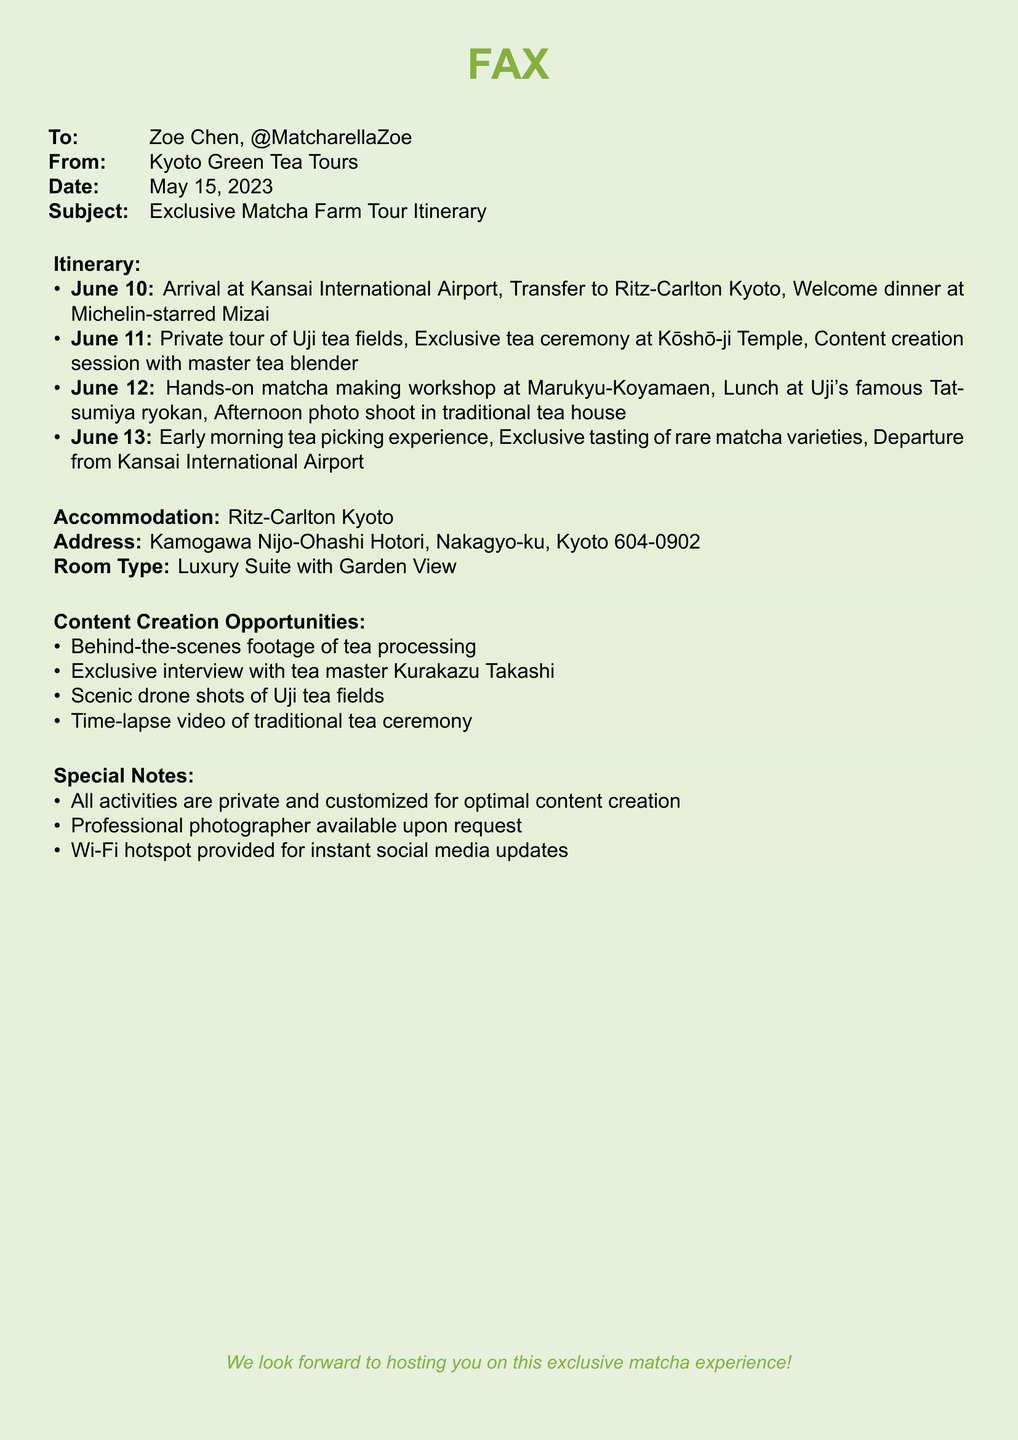What is the arrival date? The arrival date is mentioned in the itinerary for June 10.
Answer: June 10 What is the accommodation name? The accommodation is indicated in the document as Ritz-Carlton Kyoto.
Answer: Ritz-Carlton Kyoto Who is the content creation session with? The document states that the session is with the master tea blender.
Answer: master tea blender What type of room is booked? The details provide the room type as a Luxury Suite with Garden View.
Answer: Luxury Suite with Garden View What is one opportunity for content creation? The document lists several, one of which is behind-the-scenes footage of tea processing.
Answer: behind-the-scenes footage of tea processing How many days is the tour? The itinerary spans from June 10 to June 13, indicating a three-day tour.
Answer: three days What special availability is offered for photography? There is a mention of a professional photographer available upon request.
Answer: professional photographer What activity happens on June 12? The document describes a hands-on matcha making workshop as the main activity.
Answer: hands-on matcha making workshop What is provided for social media updates? The special note mentions that a Wi-Fi hotspot is provided for this purpose.
Answer: Wi-Fi hotspot 